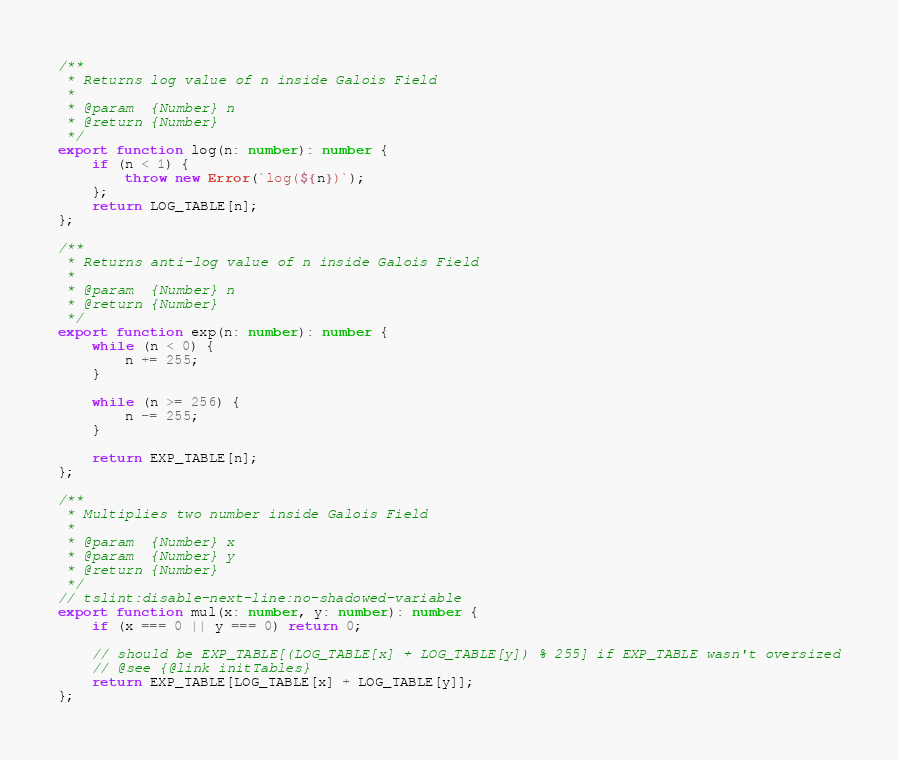Convert code to text. <code><loc_0><loc_0><loc_500><loc_500><_TypeScript_>
/**
 * Returns log value of n inside Galois Field
 *
 * @param  {Number} n
 * @return {Number}
 */
export function log(n: number): number {
    if (n < 1) {
        throw new Error(`log(${n})`);
    };
    return LOG_TABLE[n];
};

/**
 * Returns anti-log value of n inside Galois Field
 *
 * @param  {Number} n
 * @return {Number}
 */
export function exp(n: number): number {
    while (n < 0) {
        n += 255;
    }

    while (n >= 256) {
        n -= 255;
    }

    return EXP_TABLE[n];
};

/**
 * Multiplies two number inside Galois Field
 *
 * @param  {Number} x
 * @param  {Number} y
 * @return {Number}
 */
// tslint:disable-next-line:no-shadowed-variable
export function mul(x: number, y: number): number {
    if (x === 0 || y === 0) return 0;

    // should be EXP_TABLE[(LOG_TABLE[x] + LOG_TABLE[y]) % 255] if EXP_TABLE wasn't oversized
    // @see {@link initTables}
    return EXP_TABLE[LOG_TABLE[x] + LOG_TABLE[y]];
};
</code> 